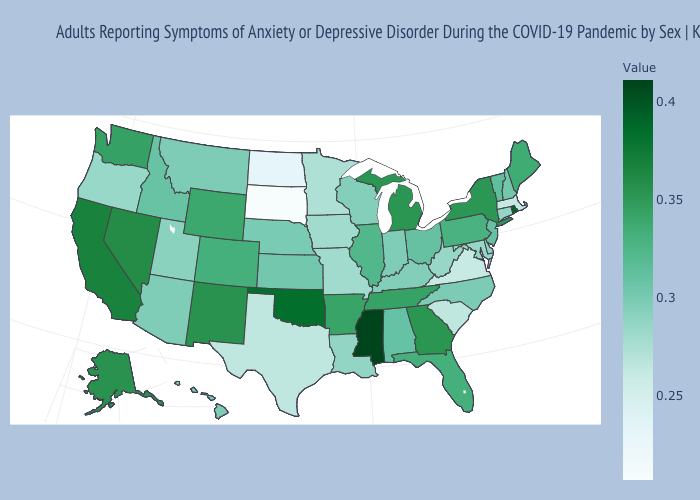Does South Dakota have the lowest value in the MidWest?
Keep it brief. Yes. Is the legend a continuous bar?
Answer briefly. Yes. 